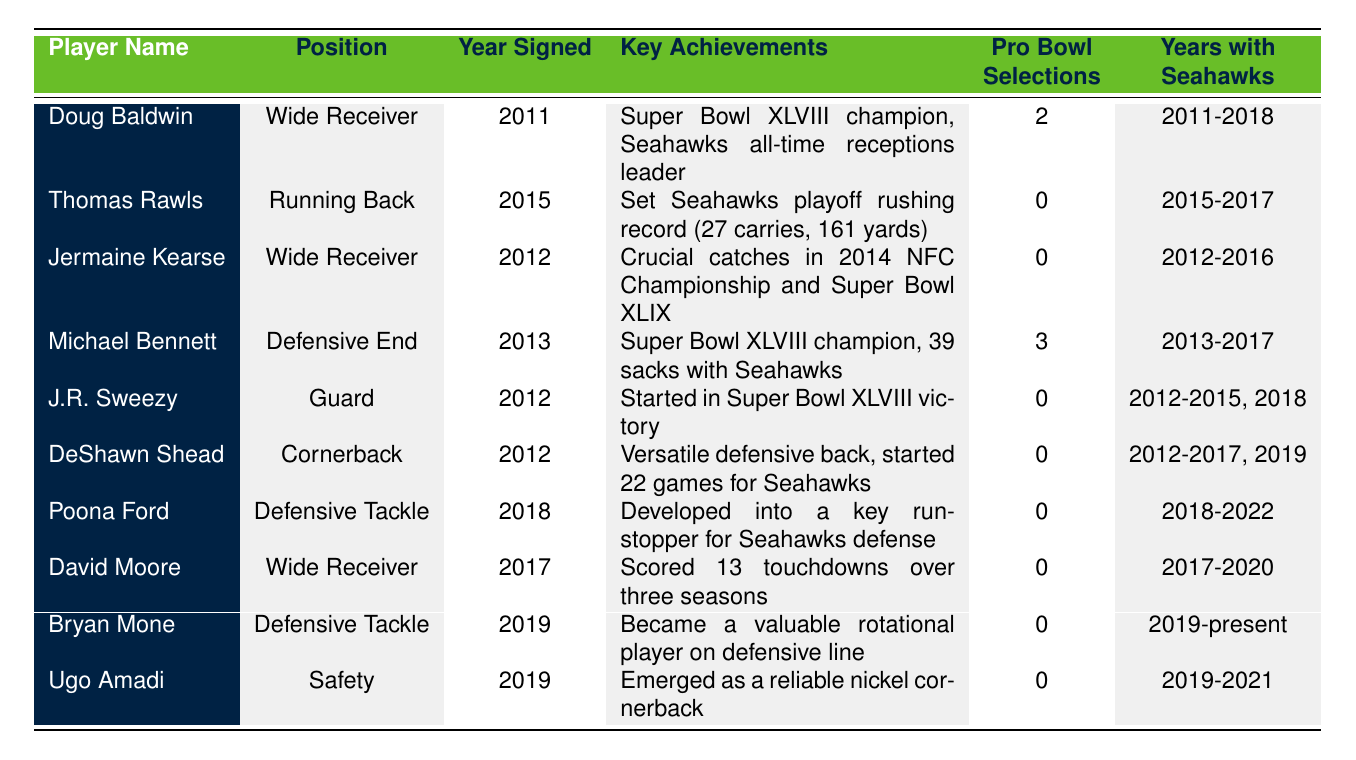What position did Doug Baldwin play for the Seahawks? The table lists Doug Baldwin's position in the second column, which is "Wide Receiver."
Answer: Wide Receiver How many Pro Bowl selections did Michael Bennett have? The Pro Bowl selections for Michael Bennett are listed in the table as 3 in the fifth column.
Answer: 3 Which player had the key achievement of starting in Super Bowl XLVIII? The table indicates that J.R. Sweezy had the achievement of starting in Super Bowl XLVIII, listed in the fourth column.
Answer: J.R. Sweezy How many years did Jermaine Kearse play with the Seahawks? The table shows that Jermaine Kearse played with the Seahawks from 2012 to 2016, which totals 5 years.
Answer: 5 Which player developed into a key run-stopper for the Seahawks defense? Poona Ford is listed as having developed into a key run-stopper in the table under key achievements.
Answer: Poona Ford Did any of the players listed have more than two Pro Bowl selections? Scanning the table shows that only Doug Baldwin (2) and Michael Bennett (3) had Pro Bowl selections; hence, only Michael Bennett had more than two.
Answer: Yes What are the names of the players who played wide receiver for the Seahawks? The players listed in the table under the position "Wide Receiver" are Doug Baldwin, Jermaine Kearse, and David Moore.
Answer: Doug Baldwin, Jermaine Kearse, David Moore How many total touchdowns did David Moore score during his time with the Seahawks? According to the table, David Moore scored 13 touchdowns over three seasons, as stated in his key achievements.
Answer: 13 Identify any player who had no Pro Bowl selections. The table shows that several players, including Thomas Rawls, Jermaine Kearse, J.R. Sweezy, DeShawn Shead, Poona Ford, David Moore, Bryan Mone, and Ugo Amadi, had 0 Pro Bowl selections.
Answer: Thomas Rawls, Jermaine Kearse, J.R. Sweezy, DeShawn Shead, Poona Ford, David Moore, Bryan Mone, Ugo Amadi Which undrafted player has the longest tenure with the Seahawks according to the table? The table shows that Doug Baldwin has the longest tenure from 2011 to 2018, totaling 8 years.
Answer: Doug Baldwin 